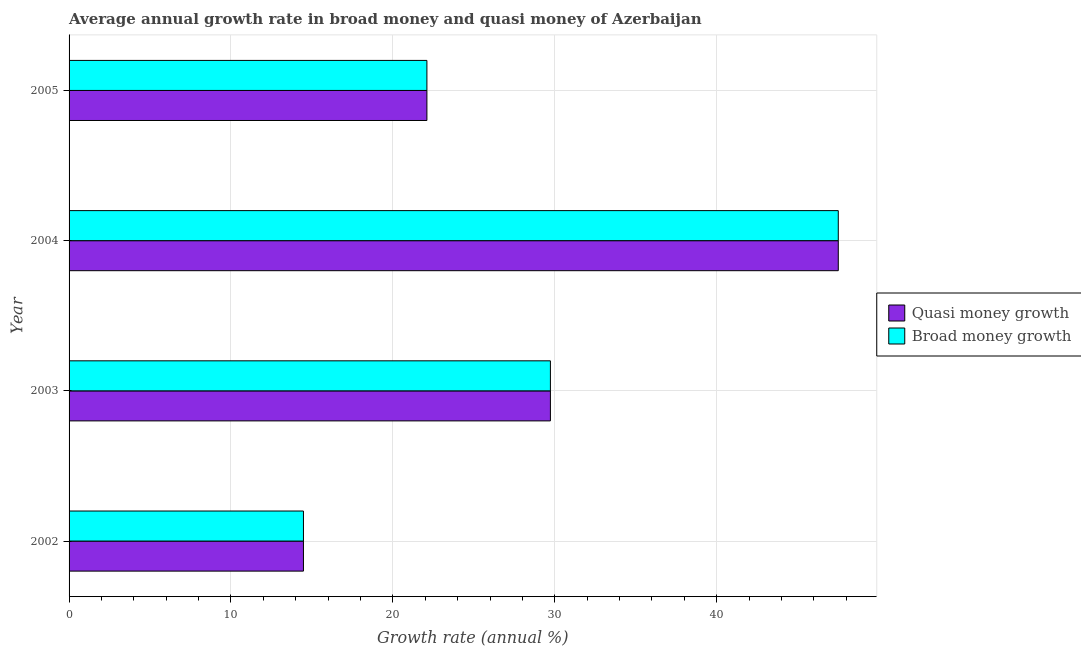How many different coloured bars are there?
Your answer should be very brief. 2. Are the number of bars per tick equal to the number of legend labels?
Offer a very short reply. Yes. How many bars are there on the 4th tick from the bottom?
Your answer should be very brief. 2. What is the label of the 4th group of bars from the top?
Offer a terse response. 2002. In how many cases, is the number of bars for a given year not equal to the number of legend labels?
Your response must be concise. 0. What is the annual growth rate in broad money in 2004?
Your answer should be compact. 47.51. Across all years, what is the maximum annual growth rate in quasi money?
Give a very brief answer. 47.51. Across all years, what is the minimum annual growth rate in quasi money?
Ensure brevity in your answer.  14.48. What is the total annual growth rate in broad money in the graph?
Keep it short and to the point. 113.82. What is the difference between the annual growth rate in quasi money in 2004 and that in 2005?
Offer a very short reply. 25.41. What is the difference between the annual growth rate in broad money in 2004 and the annual growth rate in quasi money in 2005?
Ensure brevity in your answer.  25.41. What is the average annual growth rate in quasi money per year?
Make the answer very short. 28.45. What is the ratio of the annual growth rate in broad money in 2003 to that in 2004?
Offer a very short reply. 0.63. Is the difference between the annual growth rate in quasi money in 2003 and 2005 greater than the difference between the annual growth rate in broad money in 2003 and 2005?
Make the answer very short. No. What is the difference between the highest and the second highest annual growth rate in broad money?
Your response must be concise. 17.78. What is the difference between the highest and the lowest annual growth rate in broad money?
Your answer should be compact. 33.03. In how many years, is the annual growth rate in quasi money greater than the average annual growth rate in quasi money taken over all years?
Ensure brevity in your answer.  2. What does the 2nd bar from the top in 2002 represents?
Ensure brevity in your answer.  Quasi money growth. What does the 1st bar from the bottom in 2005 represents?
Provide a succinct answer. Quasi money growth. How many bars are there?
Provide a short and direct response. 8. How many years are there in the graph?
Give a very brief answer. 4. What is the difference between two consecutive major ticks on the X-axis?
Keep it short and to the point. 10. Does the graph contain any zero values?
Provide a short and direct response. No. Where does the legend appear in the graph?
Provide a short and direct response. Center right. How many legend labels are there?
Your answer should be compact. 2. How are the legend labels stacked?
Your answer should be compact. Vertical. What is the title of the graph?
Your response must be concise. Average annual growth rate in broad money and quasi money of Azerbaijan. What is the label or title of the X-axis?
Your answer should be very brief. Growth rate (annual %). What is the Growth rate (annual %) in Quasi money growth in 2002?
Your answer should be compact. 14.48. What is the Growth rate (annual %) in Broad money growth in 2002?
Offer a very short reply. 14.48. What is the Growth rate (annual %) in Quasi money growth in 2003?
Your answer should be compact. 29.73. What is the Growth rate (annual %) in Broad money growth in 2003?
Offer a very short reply. 29.73. What is the Growth rate (annual %) in Quasi money growth in 2004?
Keep it short and to the point. 47.51. What is the Growth rate (annual %) in Broad money growth in 2004?
Your answer should be compact. 47.51. What is the Growth rate (annual %) of Quasi money growth in 2005?
Keep it short and to the point. 22.1. What is the Growth rate (annual %) in Broad money growth in 2005?
Your response must be concise. 22.1. Across all years, what is the maximum Growth rate (annual %) of Quasi money growth?
Your answer should be very brief. 47.51. Across all years, what is the maximum Growth rate (annual %) in Broad money growth?
Keep it short and to the point. 47.51. Across all years, what is the minimum Growth rate (annual %) of Quasi money growth?
Ensure brevity in your answer.  14.48. Across all years, what is the minimum Growth rate (annual %) in Broad money growth?
Give a very brief answer. 14.48. What is the total Growth rate (annual %) of Quasi money growth in the graph?
Provide a succinct answer. 113.82. What is the total Growth rate (annual %) of Broad money growth in the graph?
Ensure brevity in your answer.  113.82. What is the difference between the Growth rate (annual %) of Quasi money growth in 2002 and that in 2003?
Your answer should be very brief. -15.25. What is the difference between the Growth rate (annual %) of Broad money growth in 2002 and that in 2003?
Offer a very short reply. -15.25. What is the difference between the Growth rate (annual %) of Quasi money growth in 2002 and that in 2004?
Give a very brief answer. -33.03. What is the difference between the Growth rate (annual %) in Broad money growth in 2002 and that in 2004?
Your answer should be very brief. -33.03. What is the difference between the Growth rate (annual %) in Quasi money growth in 2002 and that in 2005?
Keep it short and to the point. -7.63. What is the difference between the Growth rate (annual %) in Broad money growth in 2002 and that in 2005?
Your answer should be very brief. -7.63. What is the difference between the Growth rate (annual %) in Quasi money growth in 2003 and that in 2004?
Ensure brevity in your answer.  -17.78. What is the difference between the Growth rate (annual %) of Broad money growth in 2003 and that in 2004?
Your answer should be compact. -17.78. What is the difference between the Growth rate (annual %) of Quasi money growth in 2003 and that in 2005?
Your response must be concise. 7.63. What is the difference between the Growth rate (annual %) of Broad money growth in 2003 and that in 2005?
Your answer should be compact. 7.63. What is the difference between the Growth rate (annual %) in Quasi money growth in 2004 and that in 2005?
Ensure brevity in your answer.  25.41. What is the difference between the Growth rate (annual %) in Broad money growth in 2004 and that in 2005?
Ensure brevity in your answer.  25.41. What is the difference between the Growth rate (annual %) in Quasi money growth in 2002 and the Growth rate (annual %) in Broad money growth in 2003?
Your answer should be compact. -15.25. What is the difference between the Growth rate (annual %) in Quasi money growth in 2002 and the Growth rate (annual %) in Broad money growth in 2004?
Your response must be concise. -33.03. What is the difference between the Growth rate (annual %) of Quasi money growth in 2002 and the Growth rate (annual %) of Broad money growth in 2005?
Ensure brevity in your answer.  -7.63. What is the difference between the Growth rate (annual %) in Quasi money growth in 2003 and the Growth rate (annual %) in Broad money growth in 2004?
Your response must be concise. -17.78. What is the difference between the Growth rate (annual %) of Quasi money growth in 2003 and the Growth rate (annual %) of Broad money growth in 2005?
Keep it short and to the point. 7.63. What is the difference between the Growth rate (annual %) in Quasi money growth in 2004 and the Growth rate (annual %) in Broad money growth in 2005?
Provide a succinct answer. 25.41. What is the average Growth rate (annual %) of Quasi money growth per year?
Offer a very short reply. 28.46. What is the average Growth rate (annual %) in Broad money growth per year?
Offer a very short reply. 28.46. In the year 2002, what is the difference between the Growth rate (annual %) of Quasi money growth and Growth rate (annual %) of Broad money growth?
Ensure brevity in your answer.  0. In the year 2004, what is the difference between the Growth rate (annual %) in Quasi money growth and Growth rate (annual %) in Broad money growth?
Provide a short and direct response. 0. What is the ratio of the Growth rate (annual %) in Quasi money growth in 2002 to that in 2003?
Your response must be concise. 0.49. What is the ratio of the Growth rate (annual %) of Broad money growth in 2002 to that in 2003?
Offer a terse response. 0.49. What is the ratio of the Growth rate (annual %) in Quasi money growth in 2002 to that in 2004?
Your answer should be very brief. 0.3. What is the ratio of the Growth rate (annual %) in Broad money growth in 2002 to that in 2004?
Your answer should be compact. 0.3. What is the ratio of the Growth rate (annual %) of Quasi money growth in 2002 to that in 2005?
Your answer should be compact. 0.66. What is the ratio of the Growth rate (annual %) of Broad money growth in 2002 to that in 2005?
Offer a terse response. 0.66. What is the ratio of the Growth rate (annual %) of Quasi money growth in 2003 to that in 2004?
Keep it short and to the point. 0.63. What is the ratio of the Growth rate (annual %) of Broad money growth in 2003 to that in 2004?
Offer a terse response. 0.63. What is the ratio of the Growth rate (annual %) of Quasi money growth in 2003 to that in 2005?
Offer a terse response. 1.35. What is the ratio of the Growth rate (annual %) of Broad money growth in 2003 to that in 2005?
Make the answer very short. 1.35. What is the ratio of the Growth rate (annual %) of Quasi money growth in 2004 to that in 2005?
Provide a succinct answer. 2.15. What is the ratio of the Growth rate (annual %) of Broad money growth in 2004 to that in 2005?
Keep it short and to the point. 2.15. What is the difference between the highest and the second highest Growth rate (annual %) in Quasi money growth?
Your answer should be compact. 17.78. What is the difference between the highest and the second highest Growth rate (annual %) in Broad money growth?
Keep it short and to the point. 17.78. What is the difference between the highest and the lowest Growth rate (annual %) of Quasi money growth?
Ensure brevity in your answer.  33.03. What is the difference between the highest and the lowest Growth rate (annual %) in Broad money growth?
Provide a succinct answer. 33.03. 